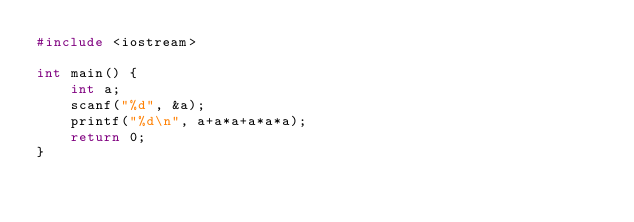Convert code to text. <code><loc_0><loc_0><loc_500><loc_500><_C++_>#include <iostream>

int main() {
    int a;
    scanf("%d", &a);
    printf("%d\n", a+a*a+a*a*a);
    return 0;
}</code> 